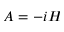Convert formula to latex. <formula><loc_0><loc_0><loc_500><loc_500>A = - i H</formula> 